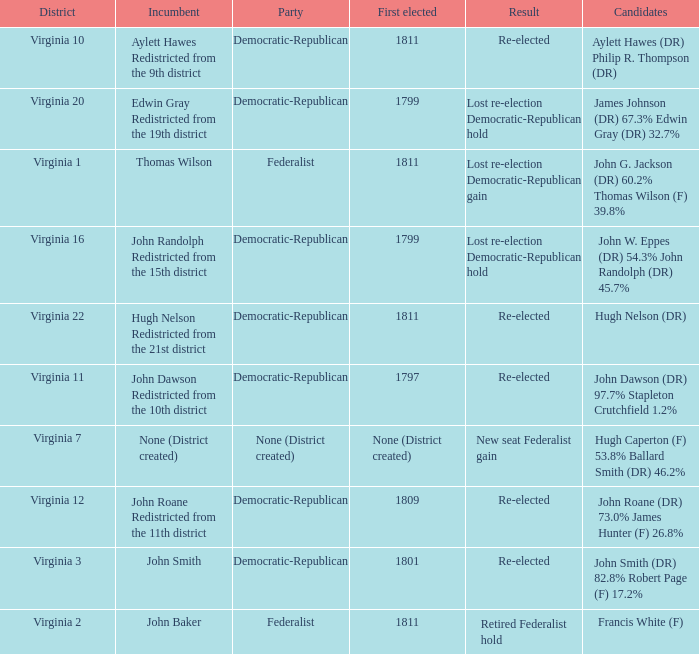Name the party for virginia 12 Democratic-Republican. 